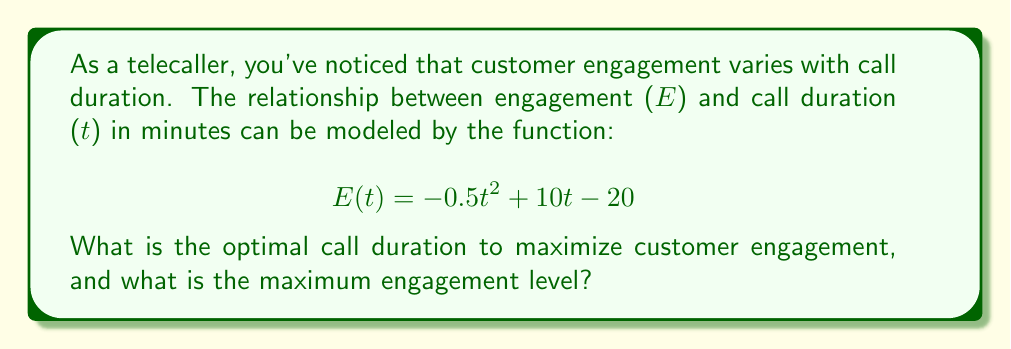Could you help me with this problem? To find the optimal call duration and maximum engagement, we need to follow these steps:

1) The function $E(t) = -0.5t^2 + 10t - 20$ is a quadratic function, which forms a parabola when graphed. The maximum point of this parabola will give us the optimal call duration and maximum engagement.

2) To find the maximum point, we need to find the vertex of the parabola. For a quadratic function in the form $f(x) = ax^2 + bx + c$, the x-coordinate of the vertex is given by $x = -\frac{b}{2a}$.

3) In our function, $a = -0.5$, $b = 10$, and $c = -20$. Let's substitute these values:

   $t = -\frac{10}{2(-0.5)} = -\frac{10}{-1} = 10$

4) This means the optimal call duration is 10 minutes.

5) To find the maximum engagement level, we need to calculate $E(10)$:

   $E(10) = -0.5(10)^2 + 10(10) - 20$
   $= -0.5(100) + 100 - 20$
   $= -50 + 100 - 20$
   $= 30$

Therefore, the maximum engagement level is 30.
Answer: Optimal call duration: 10 minutes; Maximum engagement level: 30 